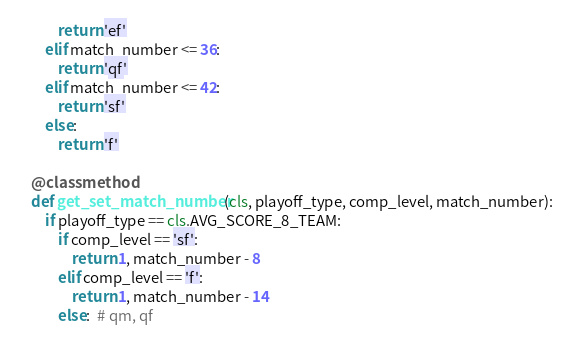<code> <loc_0><loc_0><loc_500><loc_500><_Python_>            return 'ef'
        elif match_number <= 36:
            return 'qf'
        elif match_number <= 42:
            return 'sf'
        else:
            return 'f'

    @classmethod
    def get_set_match_number(cls, playoff_type, comp_level, match_number):
        if playoff_type == cls.AVG_SCORE_8_TEAM:
            if comp_level == 'sf':
                return 1, match_number - 8
            elif comp_level == 'f':
                return 1, match_number - 14
            else:  # qm, qf</code> 